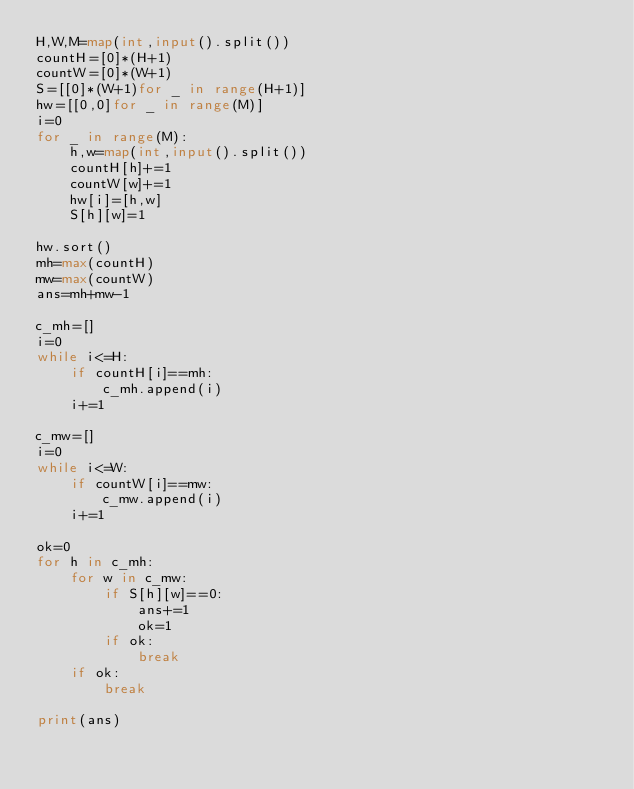Convert code to text. <code><loc_0><loc_0><loc_500><loc_500><_Python_>H,W,M=map(int,input().split())
countH=[0]*(H+1)
countW=[0]*(W+1)
S=[[0]*(W+1)for _ in range(H+1)]
hw=[[0,0]for _ in range(M)]
i=0
for _ in range(M):
    h,w=map(int,input().split())
    countH[h]+=1
    countW[w]+=1
    hw[i]=[h,w]
    S[h][w]=1

hw.sort()
mh=max(countH)
mw=max(countW)
ans=mh+mw-1

c_mh=[]
i=0
while i<=H:
    if countH[i]==mh:
        c_mh.append(i)
    i+=1

c_mw=[]
i=0
while i<=W:
    if countW[i]==mw:
        c_mw.append(i)
    i+=1

ok=0
for h in c_mh:
    for w in c_mw:
        if S[h][w]==0:
            ans+=1
            ok=1
        if ok:
            break
    if ok:
        break

print(ans)</code> 